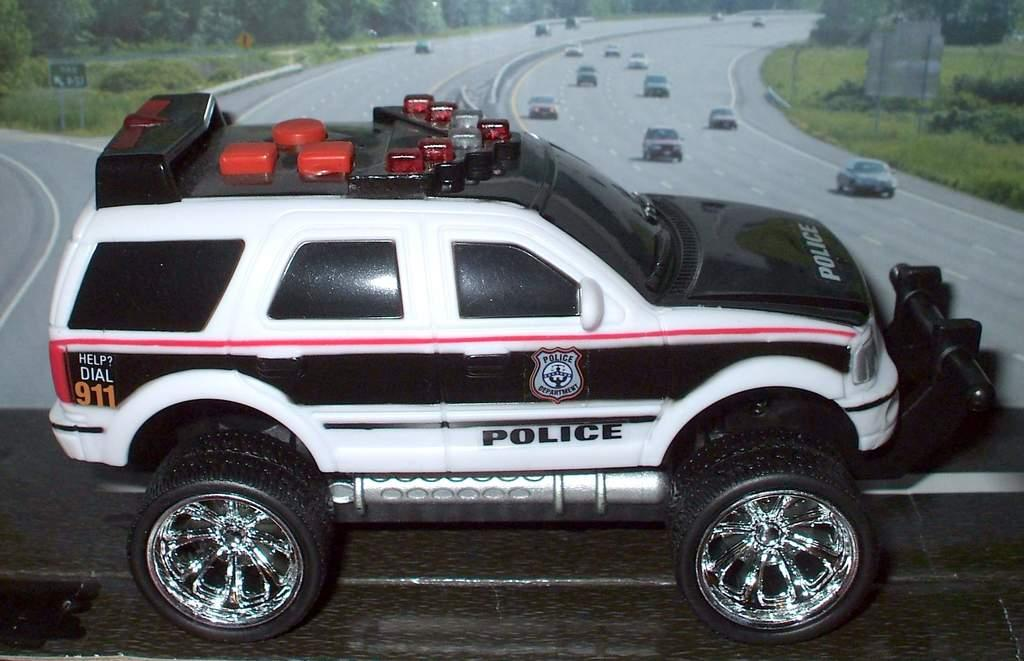What type of toy is on the table in the image? There is a toy police car on the table. What can be seen in the background of the image? There is a poster in the background. What is depicted on the poster? The poster shows trees and cars moving on the road. What type of pleasure can be seen enjoying breakfast in the image? There is no indication of anyone enjoying breakfast or experiencing pleasure in the image. 